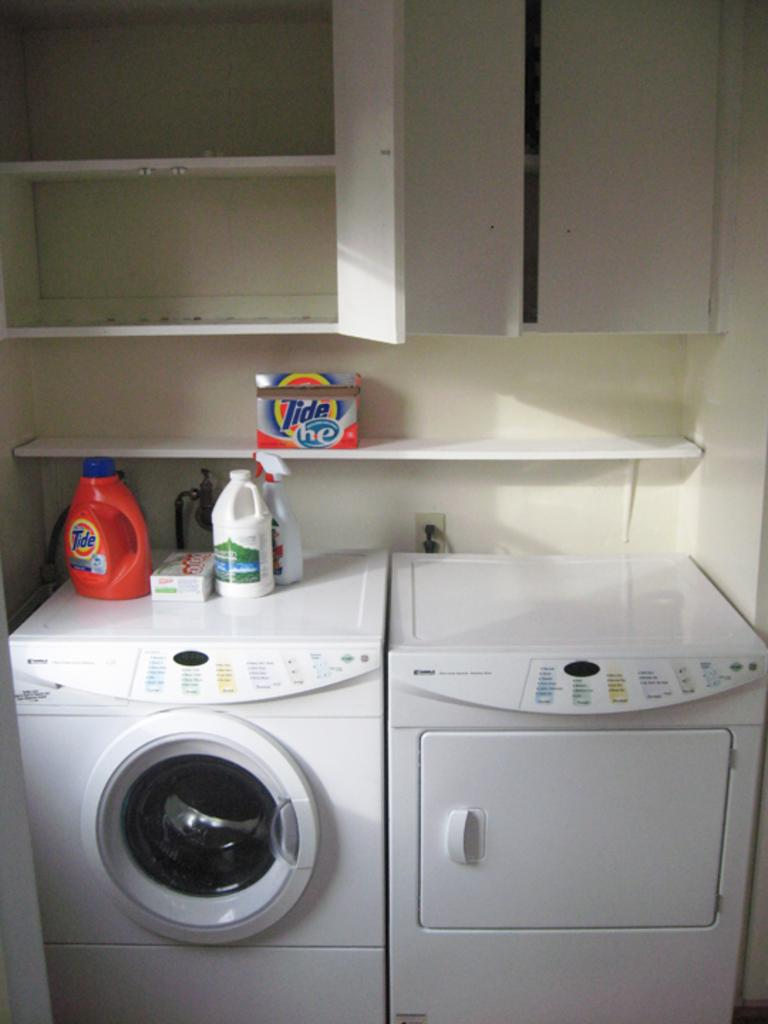What appliance is present in the image? There is a washing machine in the image. What color is the washing machine? The washing machine is white in color. What else can be seen on top of the washing machine? There are bottles on top of the washing machine. Are there any storage units visible in the image? Yes, there are cupboards in the image. How many sisters are standing next to the washing machine in the image? There are no people, including sisters, present in the image. What type of camera is used to take the picture of the washing machine? The image does not provide information about the camera used to take the picture. 